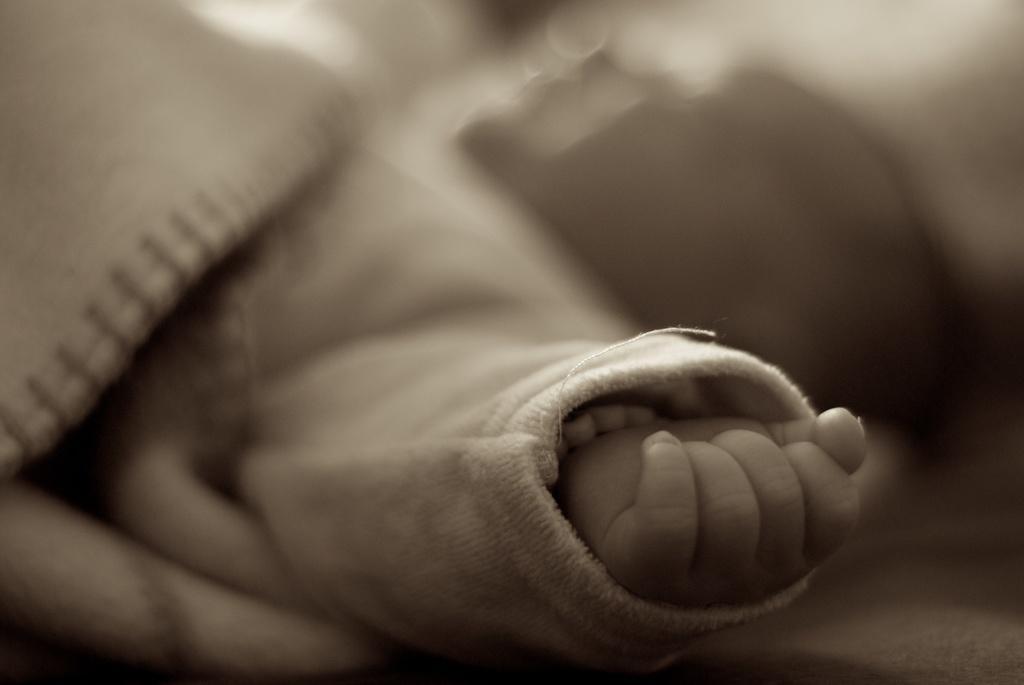Please provide a concise description of this image. In this picture we can see hand of a kid and there is a blur background. 